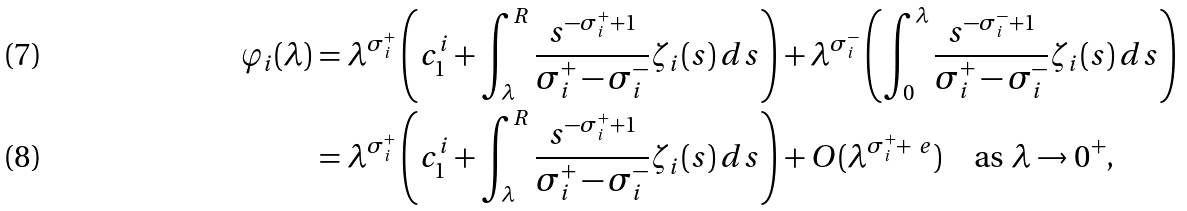<formula> <loc_0><loc_0><loc_500><loc_500>\varphi _ { i } ( \lambda ) & = \lambda ^ { \sigma ^ { + } _ { i } } \left ( c _ { 1 } ^ { i } + \int _ { \lambda } ^ { R } \frac { s ^ { - \sigma ^ { + } _ { i } + 1 } } { \sigma ^ { + } _ { i } - \sigma ^ { - } _ { i } } \zeta _ { i } ( s ) \, d s \right ) + \lambda ^ { \sigma ^ { - } _ { i } } \left ( \int _ { 0 } ^ { \lambda } \frac { s ^ { - \sigma ^ { - } _ { i } + 1 } } { \sigma ^ { + } _ { i } - \sigma ^ { - } _ { i } } \zeta _ { i } ( s ) \, d s \right ) \\ & = \lambda ^ { \sigma ^ { + } _ { i } } \left ( c _ { 1 } ^ { i } + \int _ { \lambda } ^ { R } \frac { s ^ { - \sigma ^ { + } _ { i } + 1 } } { \sigma ^ { + } _ { i } - \sigma ^ { - } _ { i } } \zeta _ { i } ( s ) \, d s \right ) + O ( \lambda ^ { \sigma ^ { + } _ { i } + \ e } ) \quad \text {as } \lambda \to 0 ^ { + } ,</formula> 